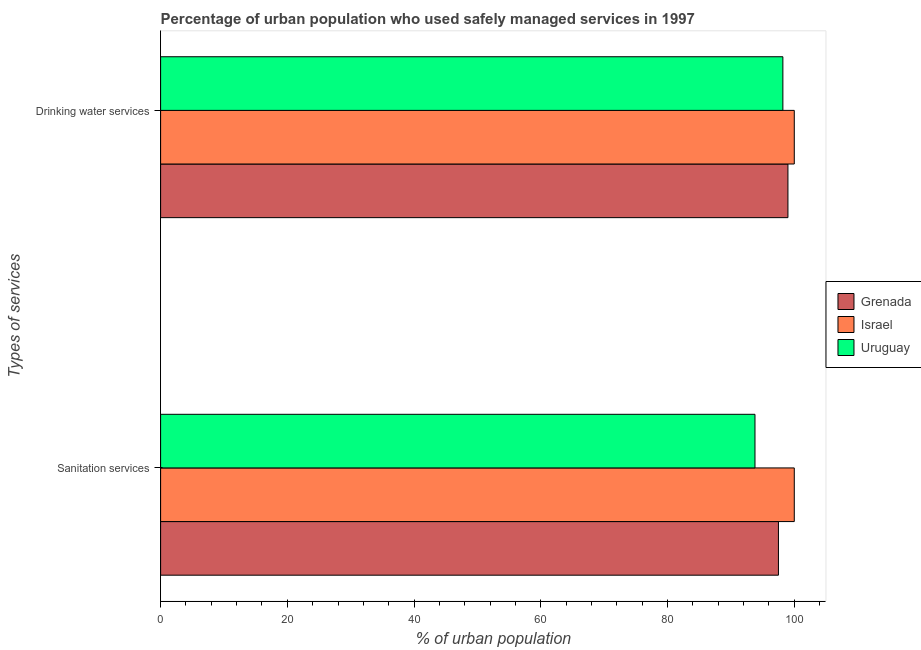Are the number of bars on each tick of the Y-axis equal?
Give a very brief answer. Yes. How many bars are there on the 2nd tick from the top?
Provide a short and direct response. 3. What is the label of the 1st group of bars from the top?
Give a very brief answer. Drinking water services. What is the percentage of urban population who used sanitation services in Grenada?
Ensure brevity in your answer.  97.5. Across all countries, what is the minimum percentage of urban population who used sanitation services?
Keep it short and to the point. 93.8. In which country was the percentage of urban population who used sanitation services minimum?
Make the answer very short. Uruguay. What is the total percentage of urban population who used sanitation services in the graph?
Give a very brief answer. 291.3. What is the difference between the percentage of urban population who used drinking water services in Grenada and the percentage of urban population who used sanitation services in Uruguay?
Offer a terse response. 5.2. What is the average percentage of urban population who used drinking water services per country?
Offer a terse response. 99.07. What is the difference between the percentage of urban population who used drinking water services and percentage of urban population who used sanitation services in Israel?
Give a very brief answer. 0. In how many countries, is the percentage of urban population who used drinking water services greater than 56 %?
Ensure brevity in your answer.  3. What is the ratio of the percentage of urban population who used sanitation services in Grenada to that in Israel?
Keep it short and to the point. 0.97. Is the percentage of urban population who used drinking water services in Grenada less than that in Israel?
Your response must be concise. Yes. In how many countries, is the percentage of urban population who used drinking water services greater than the average percentage of urban population who used drinking water services taken over all countries?
Ensure brevity in your answer.  1. What does the 2nd bar from the top in Drinking water services represents?
Make the answer very short. Israel. What does the 3rd bar from the bottom in Drinking water services represents?
Provide a short and direct response. Uruguay. How many bars are there?
Your response must be concise. 6. Are all the bars in the graph horizontal?
Your answer should be very brief. Yes. Are the values on the major ticks of X-axis written in scientific E-notation?
Your answer should be very brief. No. Does the graph contain grids?
Offer a terse response. No. Where does the legend appear in the graph?
Provide a short and direct response. Center right. What is the title of the graph?
Ensure brevity in your answer.  Percentage of urban population who used safely managed services in 1997. Does "Nicaragua" appear as one of the legend labels in the graph?
Keep it short and to the point. No. What is the label or title of the X-axis?
Make the answer very short. % of urban population. What is the label or title of the Y-axis?
Ensure brevity in your answer.  Types of services. What is the % of urban population of Grenada in Sanitation services?
Your answer should be very brief. 97.5. What is the % of urban population of Israel in Sanitation services?
Give a very brief answer. 100. What is the % of urban population of Uruguay in Sanitation services?
Offer a very short reply. 93.8. What is the % of urban population of Grenada in Drinking water services?
Provide a short and direct response. 99. What is the % of urban population in Israel in Drinking water services?
Make the answer very short. 100. What is the % of urban population of Uruguay in Drinking water services?
Your response must be concise. 98.2. Across all Types of services, what is the maximum % of urban population of Uruguay?
Your response must be concise. 98.2. Across all Types of services, what is the minimum % of urban population of Grenada?
Make the answer very short. 97.5. Across all Types of services, what is the minimum % of urban population in Uruguay?
Offer a terse response. 93.8. What is the total % of urban population in Grenada in the graph?
Your answer should be very brief. 196.5. What is the total % of urban population of Uruguay in the graph?
Offer a terse response. 192. What is the difference between the % of urban population in Grenada in Sanitation services and that in Drinking water services?
Your response must be concise. -1.5. What is the difference between the % of urban population in Israel in Sanitation services and that in Drinking water services?
Your answer should be very brief. 0. What is the difference between the % of urban population in Grenada in Sanitation services and the % of urban population in Israel in Drinking water services?
Your response must be concise. -2.5. What is the average % of urban population in Grenada per Types of services?
Offer a very short reply. 98.25. What is the average % of urban population in Uruguay per Types of services?
Your response must be concise. 96. What is the difference between the % of urban population in Grenada and % of urban population in Israel in Sanitation services?
Provide a short and direct response. -2.5. What is the difference between the % of urban population of Israel and % of urban population of Uruguay in Sanitation services?
Keep it short and to the point. 6.2. What is the difference between the % of urban population in Israel and % of urban population in Uruguay in Drinking water services?
Your answer should be very brief. 1.8. What is the ratio of the % of urban population in Grenada in Sanitation services to that in Drinking water services?
Offer a very short reply. 0.98. What is the ratio of the % of urban population of Uruguay in Sanitation services to that in Drinking water services?
Your answer should be very brief. 0.96. What is the difference between the highest and the second highest % of urban population of Grenada?
Your answer should be compact. 1.5. What is the difference between the highest and the lowest % of urban population in Grenada?
Keep it short and to the point. 1.5. What is the difference between the highest and the lowest % of urban population in Israel?
Give a very brief answer. 0. 